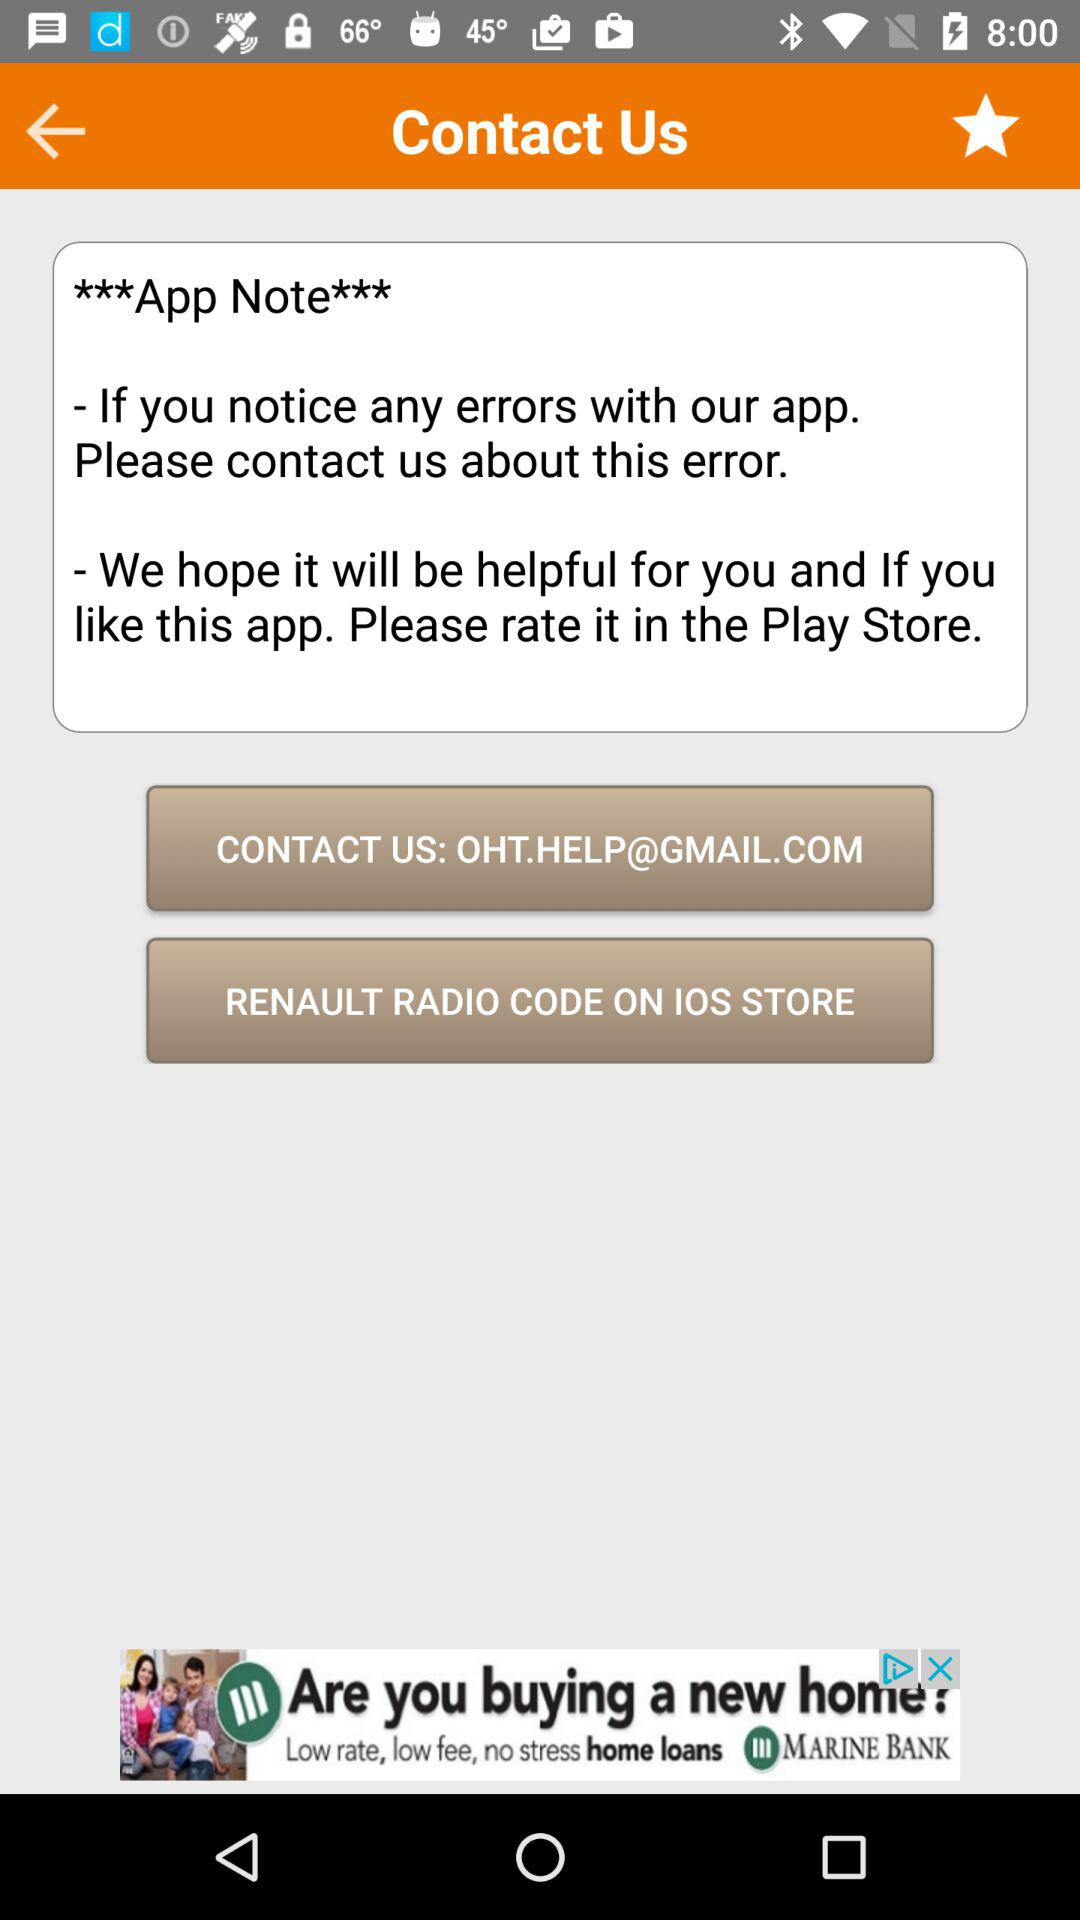In what store is the "RENAULT RADIO CODE" app available? The "RENAULT RADIO CODE" is available in the IOS store. 